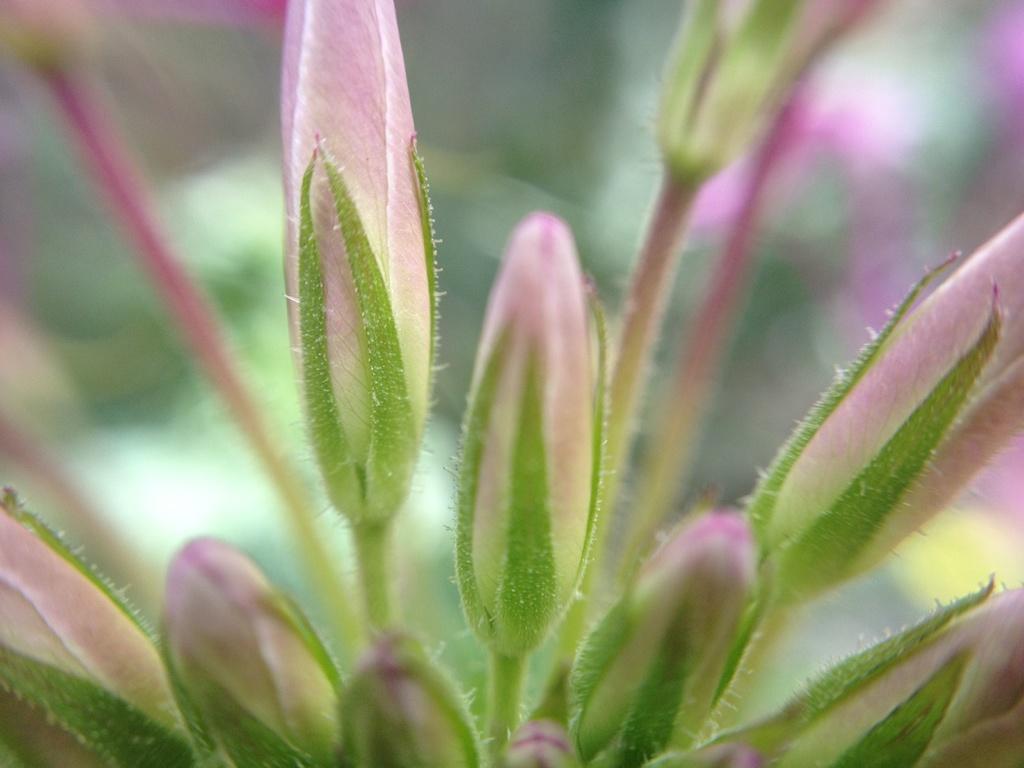Can you describe this image briefly? Here we can see buds,background it is blurry. 